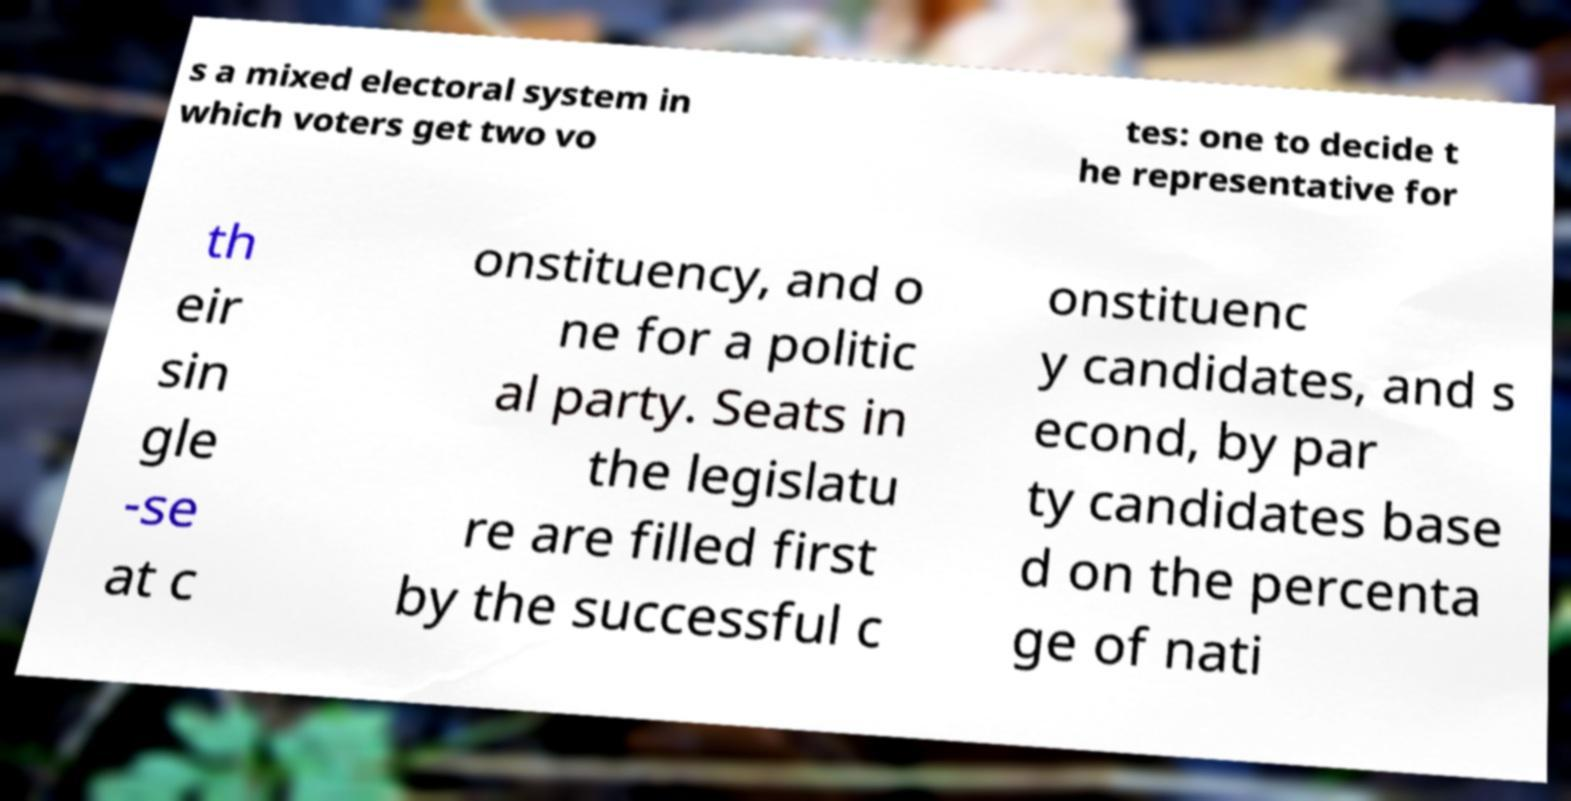Could you assist in decoding the text presented in this image and type it out clearly? s a mixed electoral system in which voters get two vo tes: one to decide t he representative for th eir sin gle -se at c onstituency, and o ne for a politic al party. Seats in the legislatu re are filled first by the successful c onstituenc y candidates, and s econd, by par ty candidates base d on the percenta ge of nati 